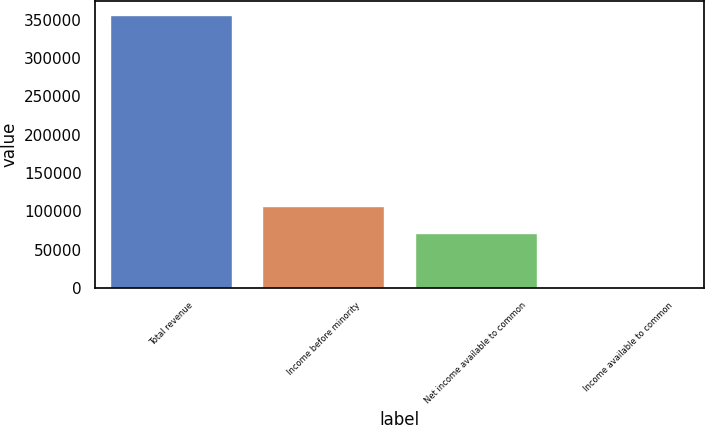<chart> <loc_0><loc_0><loc_500><loc_500><bar_chart><fcel>Total revenue<fcel>Income before minority<fcel>Net income available to common<fcel>Income available to common<nl><fcel>356104<fcel>106832<fcel>71221.3<fcel>0.59<nl></chart> 